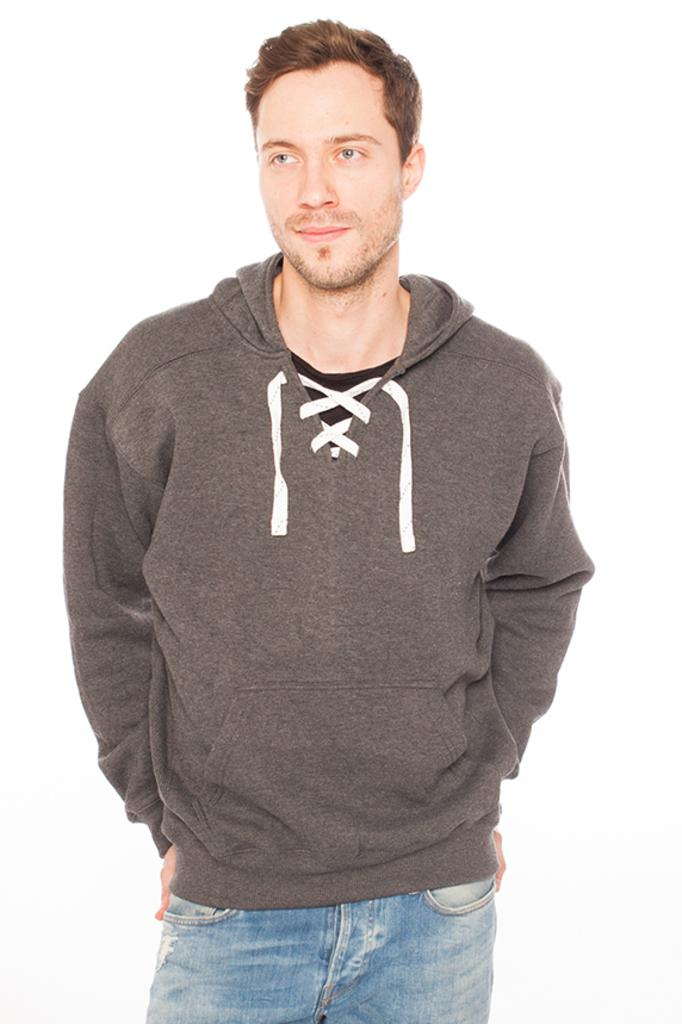Who is present in the image? There is a man in the image. What can be seen behind the man in the image? The background of the image is white. What type of furniture can be seen in the image? There is no furniture present in the image; it only features a man and a white background. 